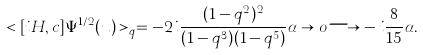<formula> <loc_0><loc_0><loc_500><loc_500>< [ i H , c ] \Psi ^ { 1 / 2 } ( u ) > _ { q } = - 2 i \frac { ( 1 - q ^ { 2 } ) ^ { 2 } } { ( 1 - q ^ { 3 } ) ( 1 - q ^ { 5 } ) } \alpha \to o { \longrightarrow } - i \frac { 8 } { 1 5 } \alpha .</formula> 